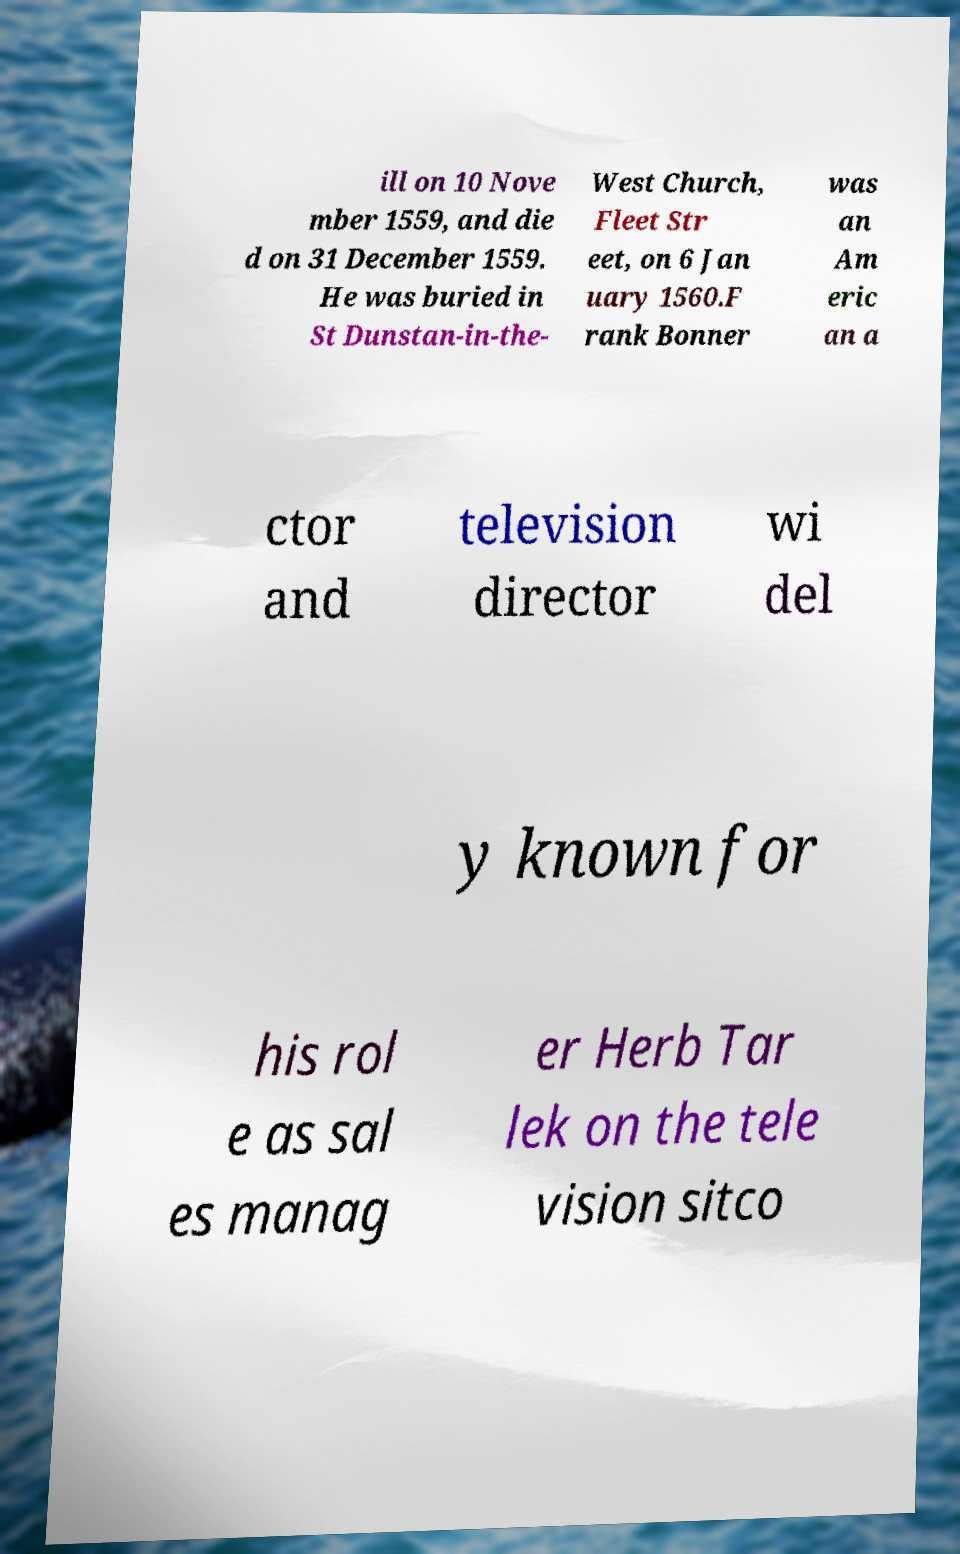Can you read and provide the text displayed in the image?This photo seems to have some interesting text. Can you extract and type it out for me? ill on 10 Nove mber 1559, and die d on 31 December 1559. He was buried in St Dunstan-in-the- West Church, Fleet Str eet, on 6 Jan uary 1560.F rank Bonner was an Am eric an a ctor and television director wi del y known for his rol e as sal es manag er Herb Tar lek on the tele vision sitco 